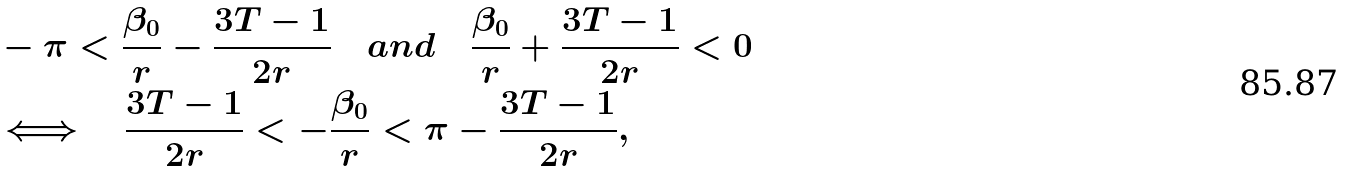<formula> <loc_0><loc_0><loc_500><loc_500>& - \pi < \frac { \beta _ { 0 } } { r } - \frac { 3 T - 1 } { 2 r } \quad a n d \quad \frac { \beta _ { 0 } } { r } + \frac { 3 T - 1 } { 2 r } < 0 \\ & \Longleftrightarrow \quad \frac { 3 T - 1 } { 2 r } < - \frac { \beta _ { 0 } } { r } < \pi - \frac { 3 T - 1 } { 2 r } ,</formula> 